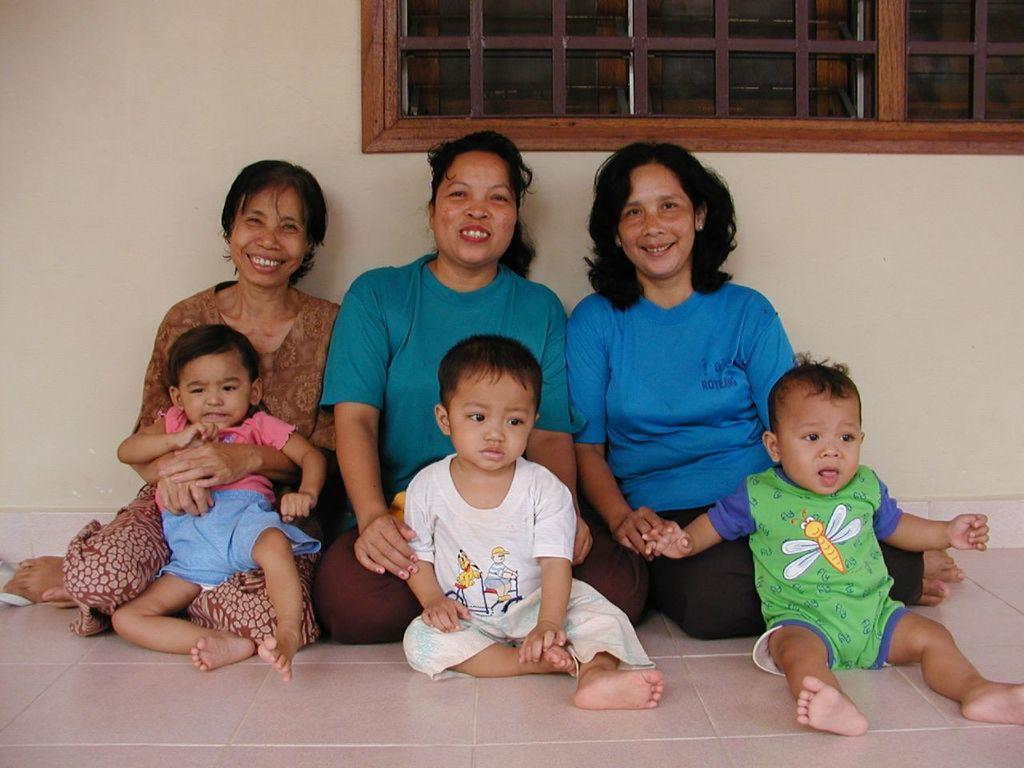How many women are in the image? There are 3 women in the image. How many children are in the image? There are 3 children in the image. What is the facial expression of the women in the image? The women are smiling. Where are the individuals in the image seated? All the individuals are sitting on the floor. What type of prison can be seen in the background of the image? There is no prison present in the image; it features 3 women and 3 children sitting on the floor. How does the fog affect the visibility of the individuals in the image? There is no fog present in the image; the individuals are clearly visible. 